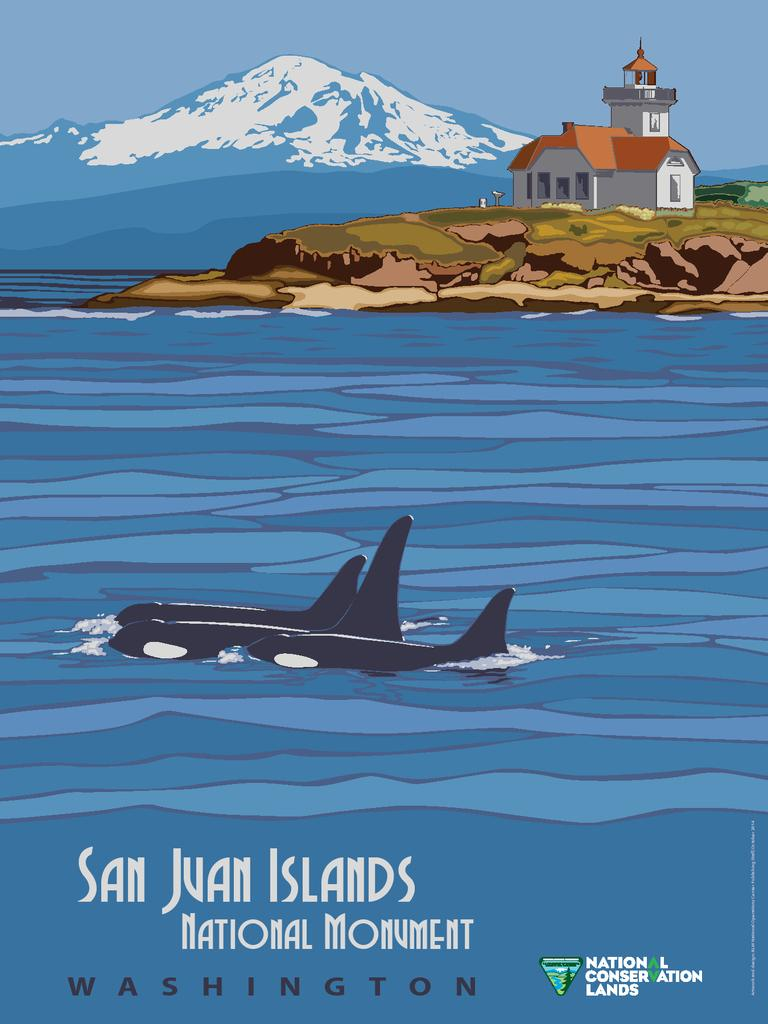<image>
Share a concise interpretation of the image provided. a poster that has National Conservation Lands written in the corner. 